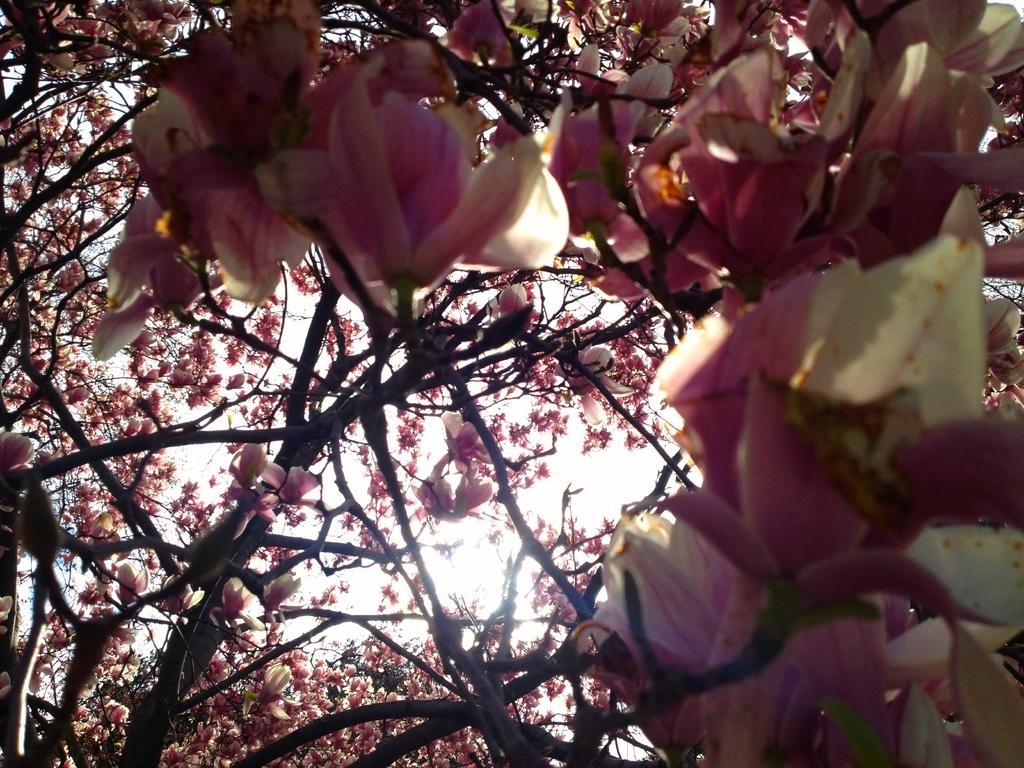What is the main subject of the picture? The main subject of the picture is a tree. What specific feature can be observed on the tree? The tree has flowers. What colors are the flowers? The flowers are in pink and white colors. What can be seen in the background of the picture? The sky is visible in the background of the picture. What type of apparel is the tree wearing in the picture? Trees do not wear apparel, so this question cannot be answered. Can you read any writing on the tree in the picture? There is no writing present on the tree in the image. 